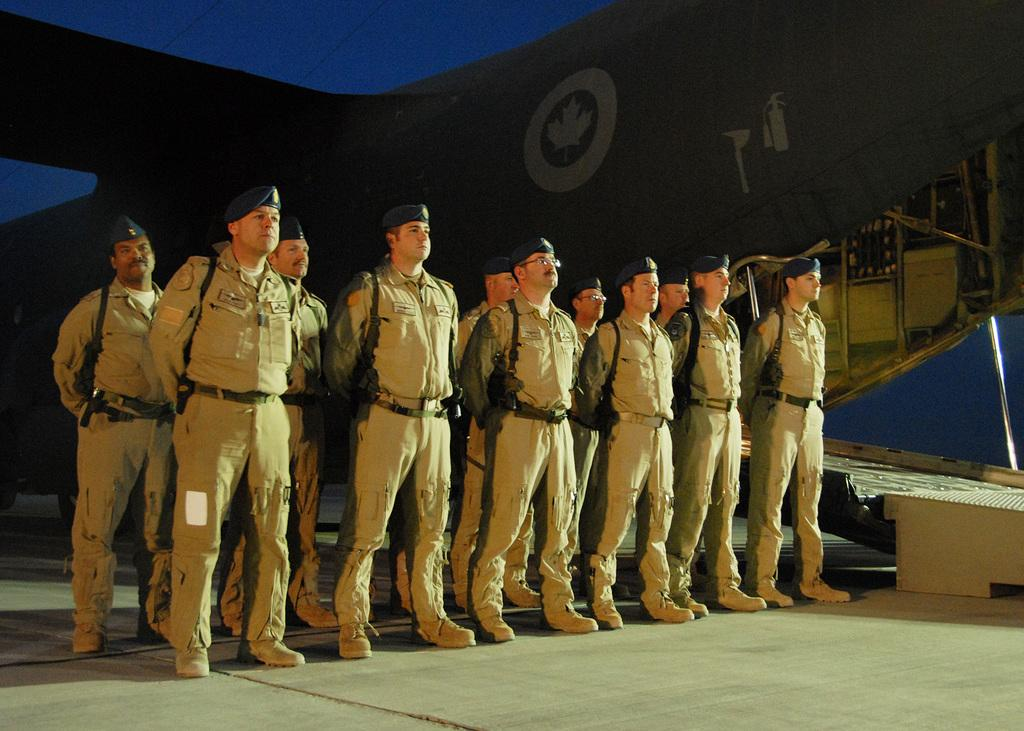What type of people can be seen in the image? There are soldiers in the image. What are the soldiers doing in the image? The soldiers are standing in the image. What are the soldiers holding in the image? The soldiers are carrying weapons on their shoulders in the image. What else can be seen in the background of the image? There are other objects in the background of the image. What type of copper star can be seen sparking in the image? There is no copper star or spark present in the image. 